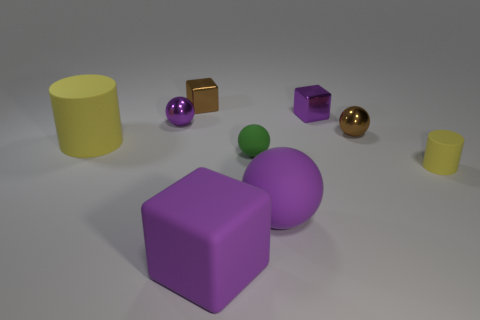Do the green sphere and the cylinder that is on the left side of the tiny matte cylinder have the same size?
Provide a succinct answer. No. Are there fewer tiny green matte things that are in front of the large rubber cube than small yellow objects?
Keep it short and to the point. Yes. There is another thing that is the same shape as the large yellow matte object; what is its material?
Offer a very short reply. Rubber. The purple object that is both behind the tiny green sphere and on the right side of the big purple cube has what shape?
Give a very brief answer. Cube. There is a brown object that is the same material as the brown ball; what is its shape?
Keep it short and to the point. Cube. What material is the big thing that is to the right of the large purple rubber cube?
Offer a very short reply. Rubber. Do the matte cylinder in front of the big matte cylinder and the yellow thing that is to the left of the small brown metal ball have the same size?
Offer a very short reply. No. The big rubber cube is what color?
Provide a short and direct response. Purple. There is a small brown thing on the right side of the green object; is its shape the same as the large yellow matte thing?
Keep it short and to the point. No. What is the small cylinder made of?
Offer a very short reply. Rubber. 